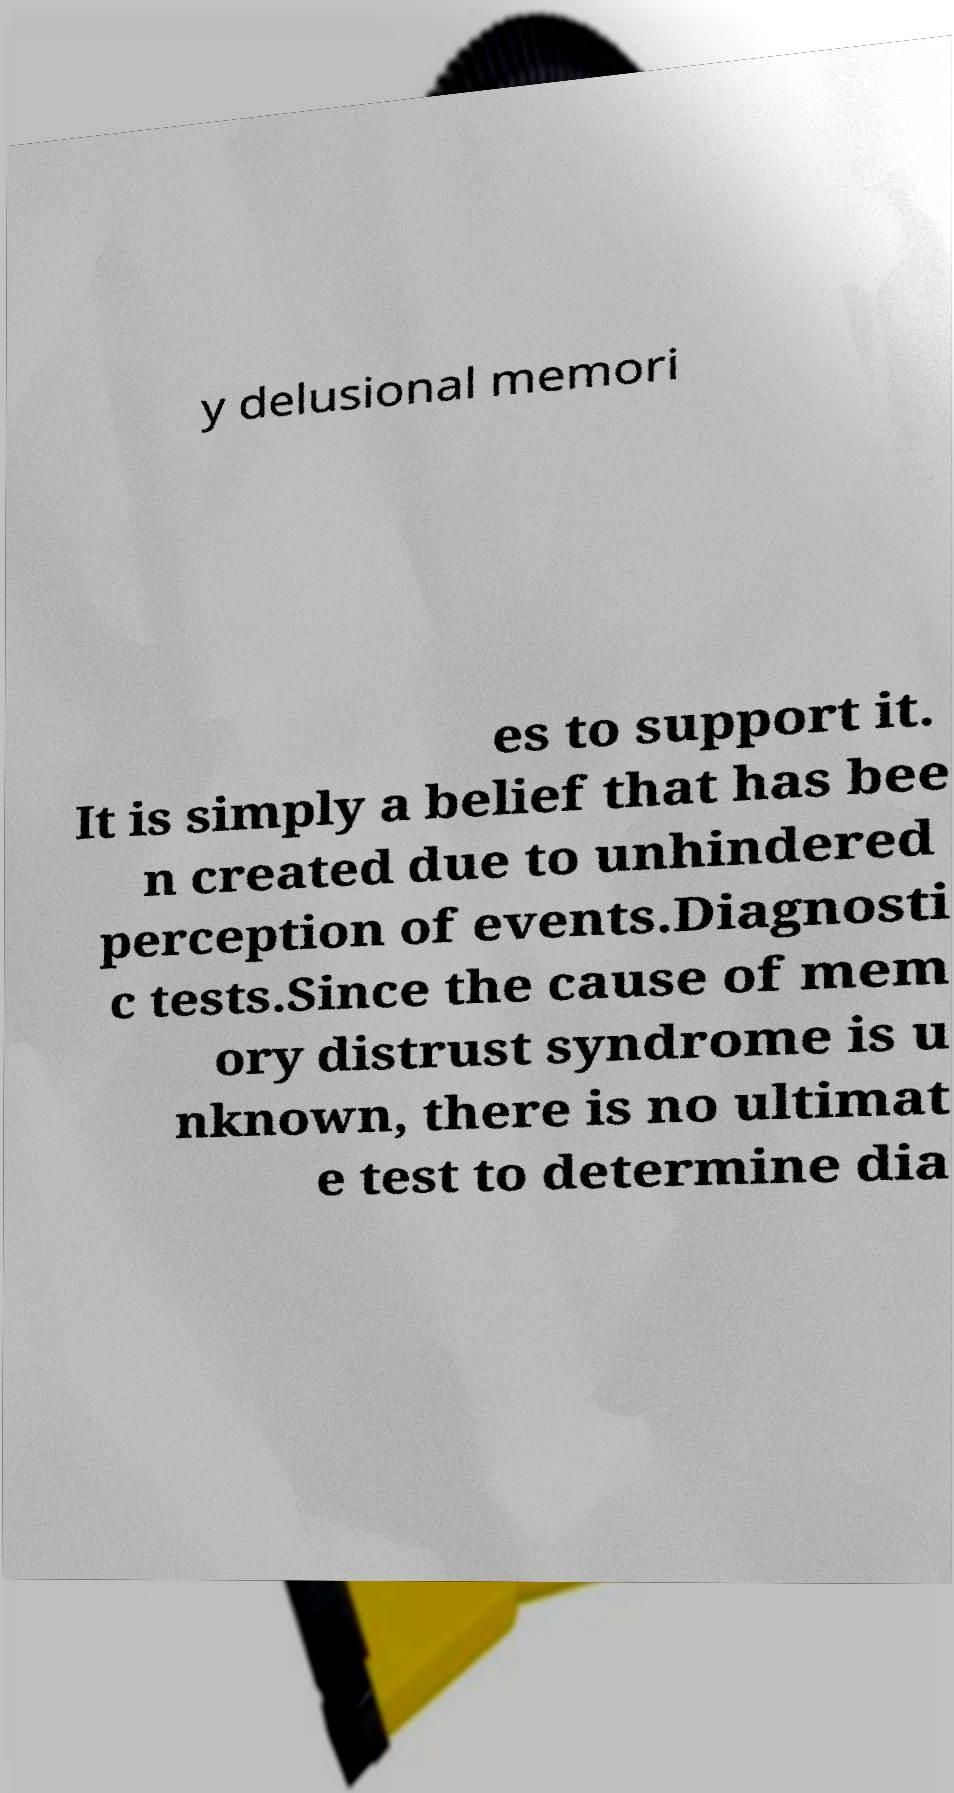What messages or text are displayed in this image? I need them in a readable, typed format. y delusional memori es to support it. It is simply a belief that has bee n created due to unhindered perception of events.Diagnosti c tests.Since the cause of mem ory distrust syndrome is u nknown, there is no ultimat e test to determine dia 